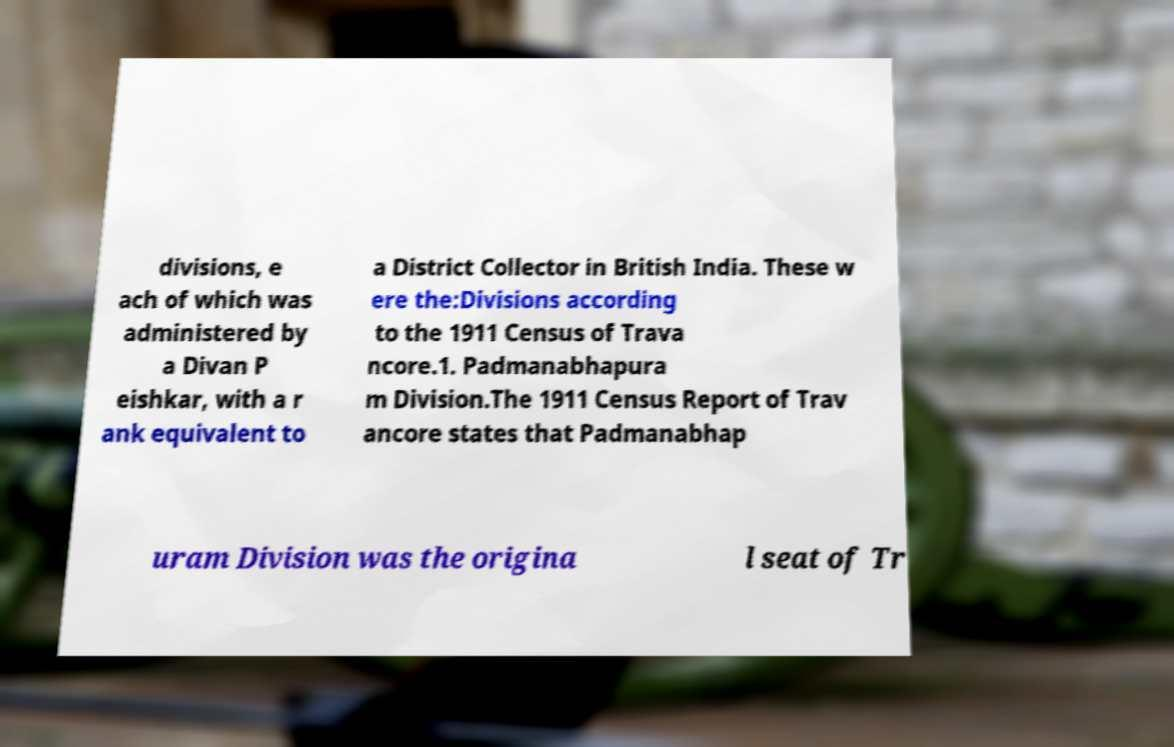Can you accurately transcribe the text from the provided image for me? divisions, e ach of which was administered by a Divan P eishkar, with a r ank equivalent to a District Collector in British India. These w ere the:Divisions according to the 1911 Census of Trava ncore.1. Padmanabhapura m Division.The 1911 Census Report of Trav ancore states that Padmanabhap uram Division was the origina l seat of Tr 